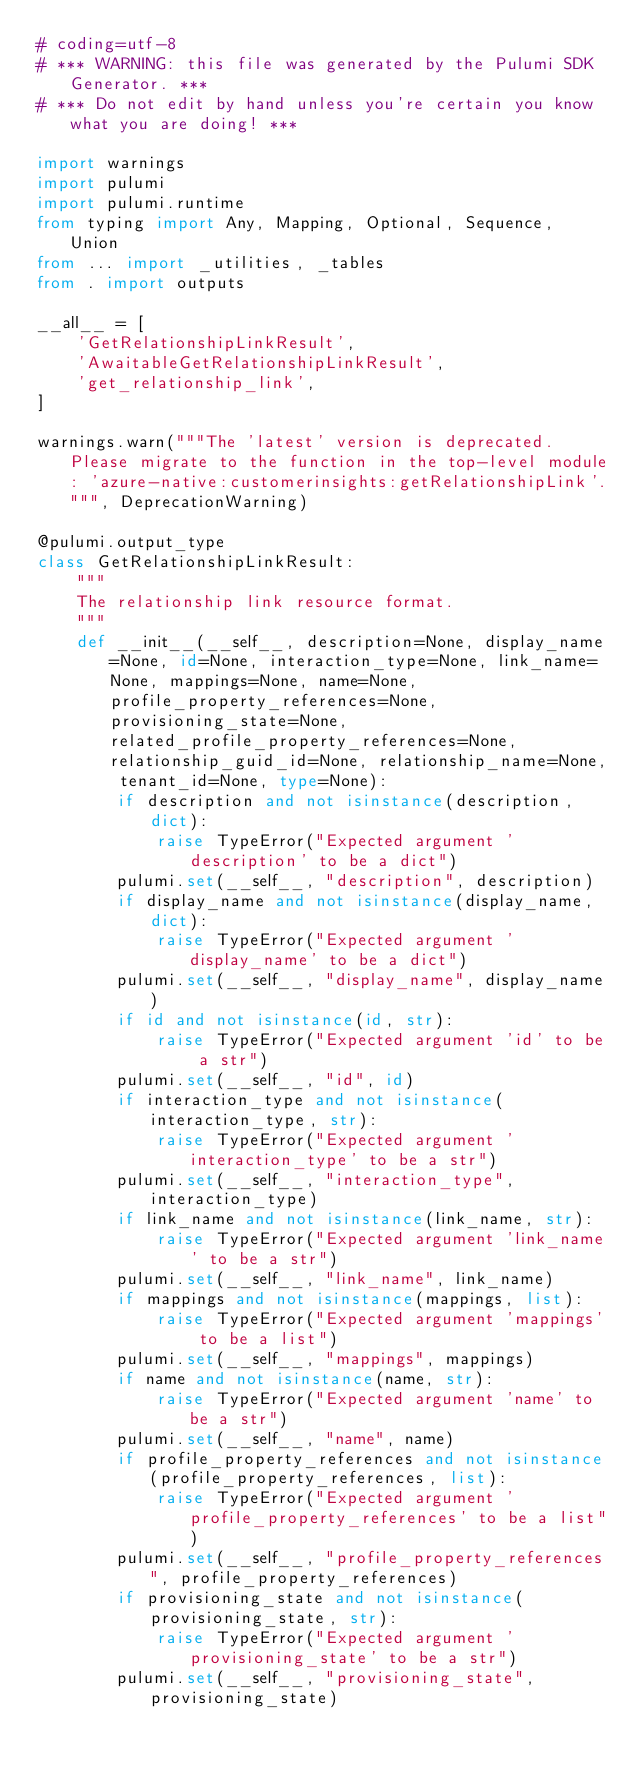Convert code to text. <code><loc_0><loc_0><loc_500><loc_500><_Python_># coding=utf-8
# *** WARNING: this file was generated by the Pulumi SDK Generator. ***
# *** Do not edit by hand unless you're certain you know what you are doing! ***

import warnings
import pulumi
import pulumi.runtime
from typing import Any, Mapping, Optional, Sequence, Union
from ... import _utilities, _tables
from . import outputs

__all__ = [
    'GetRelationshipLinkResult',
    'AwaitableGetRelationshipLinkResult',
    'get_relationship_link',
]

warnings.warn("""The 'latest' version is deprecated. Please migrate to the function in the top-level module: 'azure-native:customerinsights:getRelationshipLink'.""", DeprecationWarning)

@pulumi.output_type
class GetRelationshipLinkResult:
    """
    The relationship link resource format.
    """
    def __init__(__self__, description=None, display_name=None, id=None, interaction_type=None, link_name=None, mappings=None, name=None, profile_property_references=None, provisioning_state=None, related_profile_property_references=None, relationship_guid_id=None, relationship_name=None, tenant_id=None, type=None):
        if description and not isinstance(description, dict):
            raise TypeError("Expected argument 'description' to be a dict")
        pulumi.set(__self__, "description", description)
        if display_name and not isinstance(display_name, dict):
            raise TypeError("Expected argument 'display_name' to be a dict")
        pulumi.set(__self__, "display_name", display_name)
        if id and not isinstance(id, str):
            raise TypeError("Expected argument 'id' to be a str")
        pulumi.set(__self__, "id", id)
        if interaction_type and not isinstance(interaction_type, str):
            raise TypeError("Expected argument 'interaction_type' to be a str")
        pulumi.set(__self__, "interaction_type", interaction_type)
        if link_name and not isinstance(link_name, str):
            raise TypeError("Expected argument 'link_name' to be a str")
        pulumi.set(__self__, "link_name", link_name)
        if mappings and not isinstance(mappings, list):
            raise TypeError("Expected argument 'mappings' to be a list")
        pulumi.set(__self__, "mappings", mappings)
        if name and not isinstance(name, str):
            raise TypeError("Expected argument 'name' to be a str")
        pulumi.set(__self__, "name", name)
        if profile_property_references and not isinstance(profile_property_references, list):
            raise TypeError("Expected argument 'profile_property_references' to be a list")
        pulumi.set(__self__, "profile_property_references", profile_property_references)
        if provisioning_state and not isinstance(provisioning_state, str):
            raise TypeError("Expected argument 'provisioning_state' to be a str")
        pulumi.set(__self__, "provisioning_state", provisioning_state)</code> 